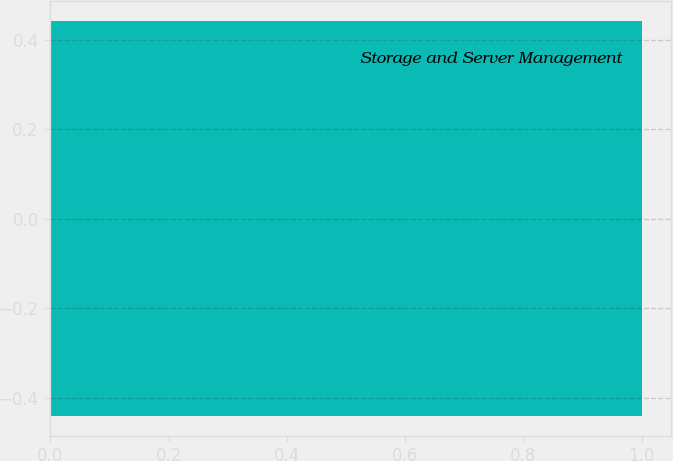Convert chart to OTSL. <chart><loc_0><loc_0><loc_500><loc_500><bar_chart><fcel>Storage and Server Management<nl><fcel>1<nl></chart> 